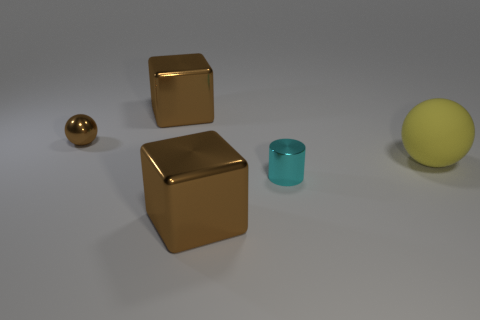Add 1 blue cylinders. How many objects exist? 6 Subtract all balls. How many objects are left? 3 Add 1 cyan metallic cylinders. How many cyan metallic cylinders exist? 2 Subtract 0 red blocks. How many objects are left? 5 Subtract all cyan cylinders. Subtract all small metal objects. How many objects are left? 2 Add 1 big yellow rubber balls. How many big yellow rubber balls are left? 2 